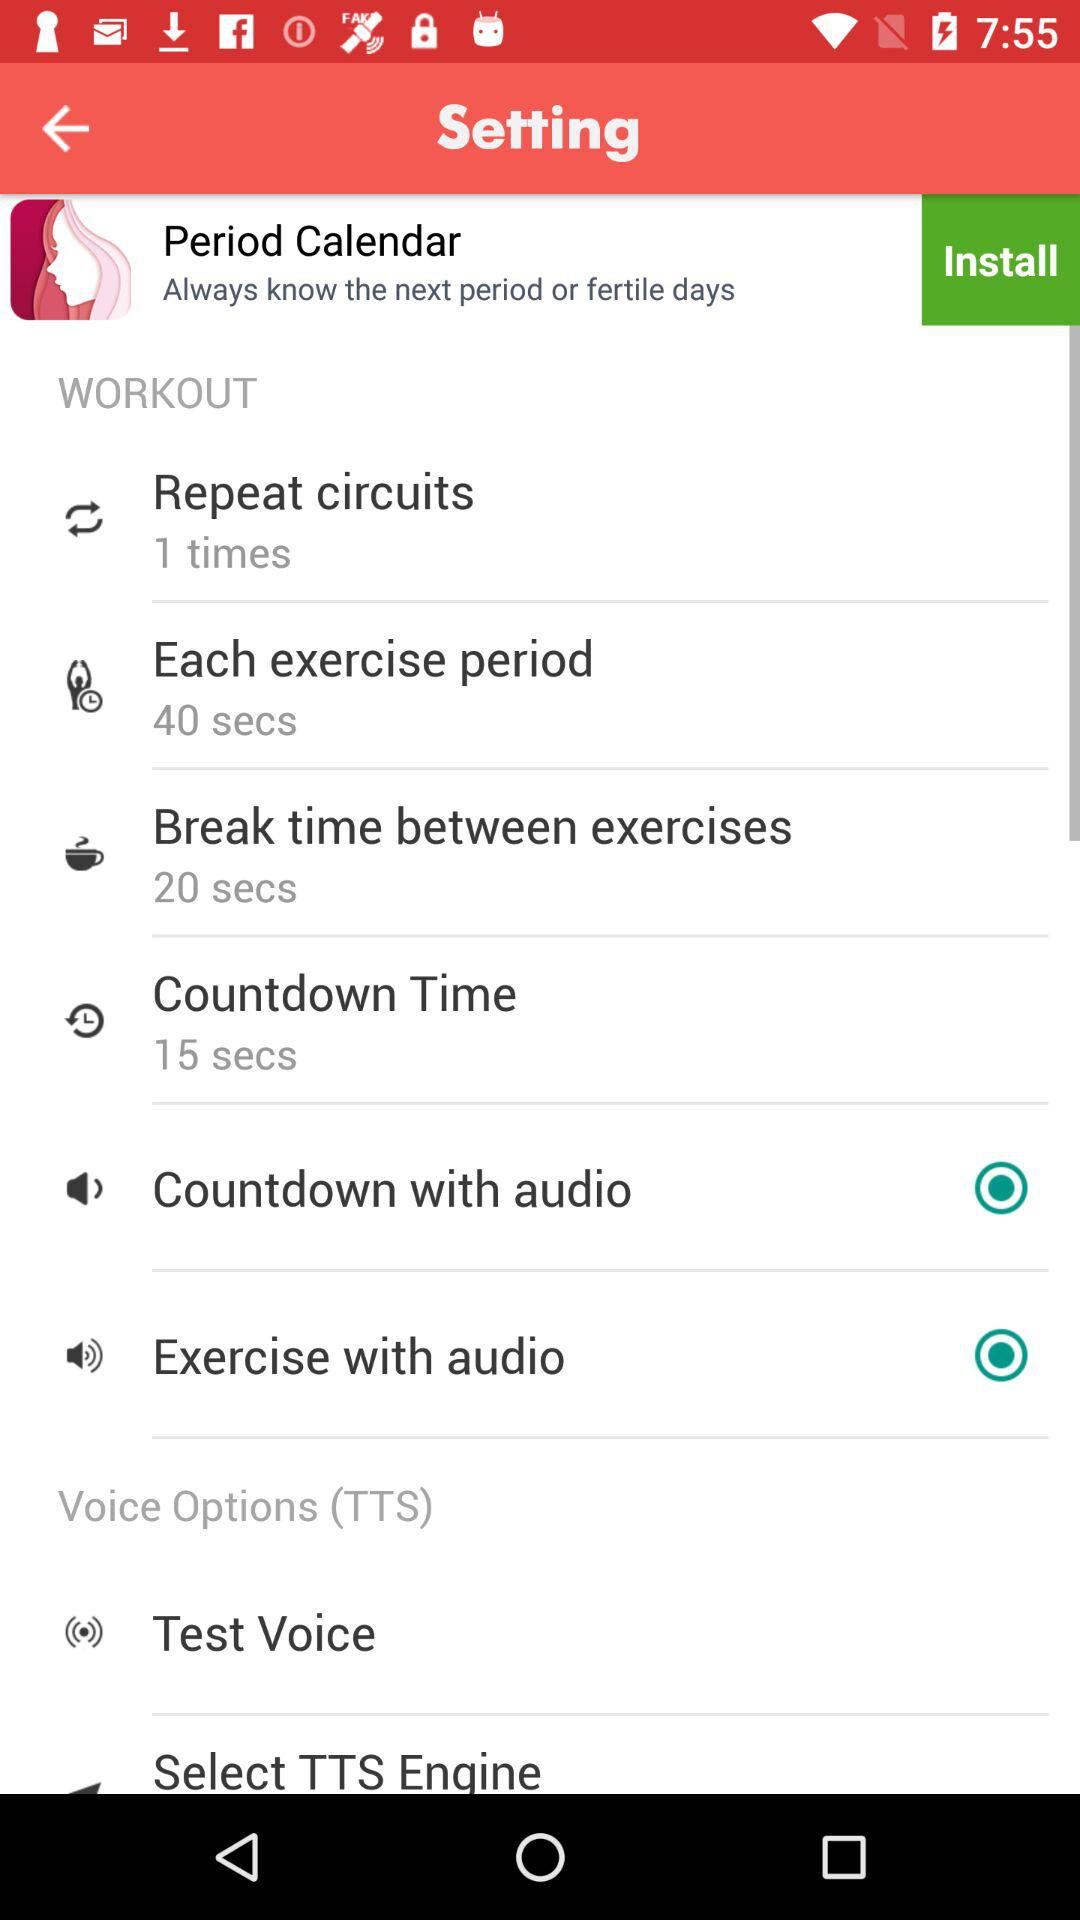What is "Each exercise period"? "Each exercise period" is 40 seconds. 